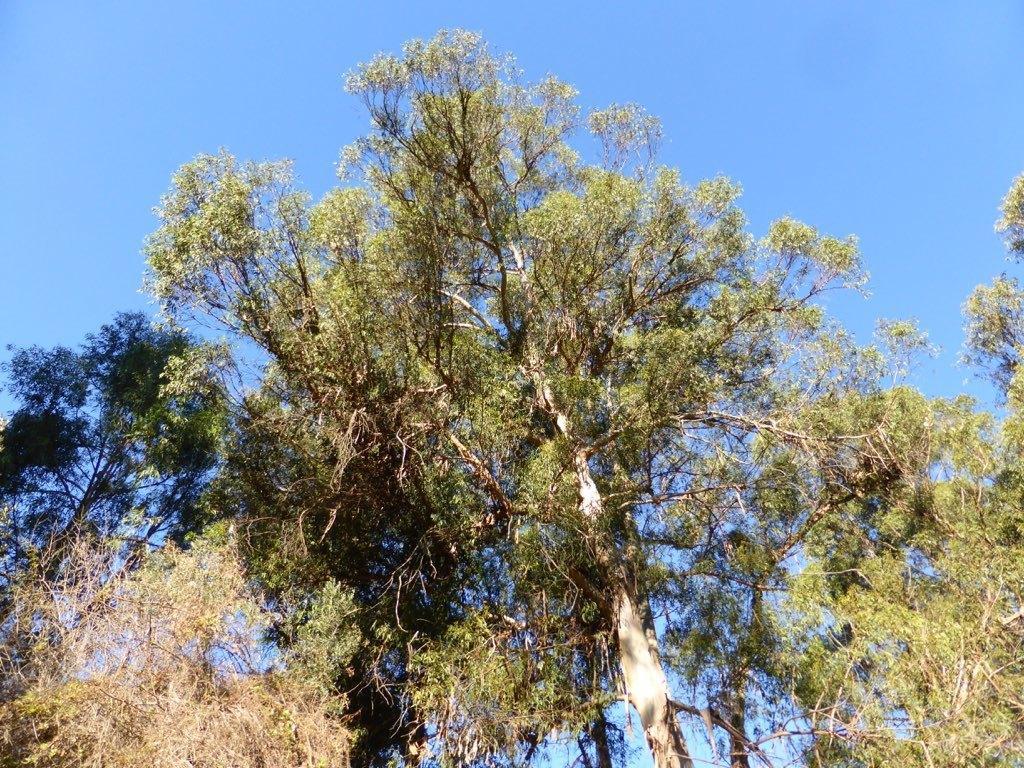Could you give a brief overview of what you see in this image? In this image we can see trees and in the background, we can see the sky. 